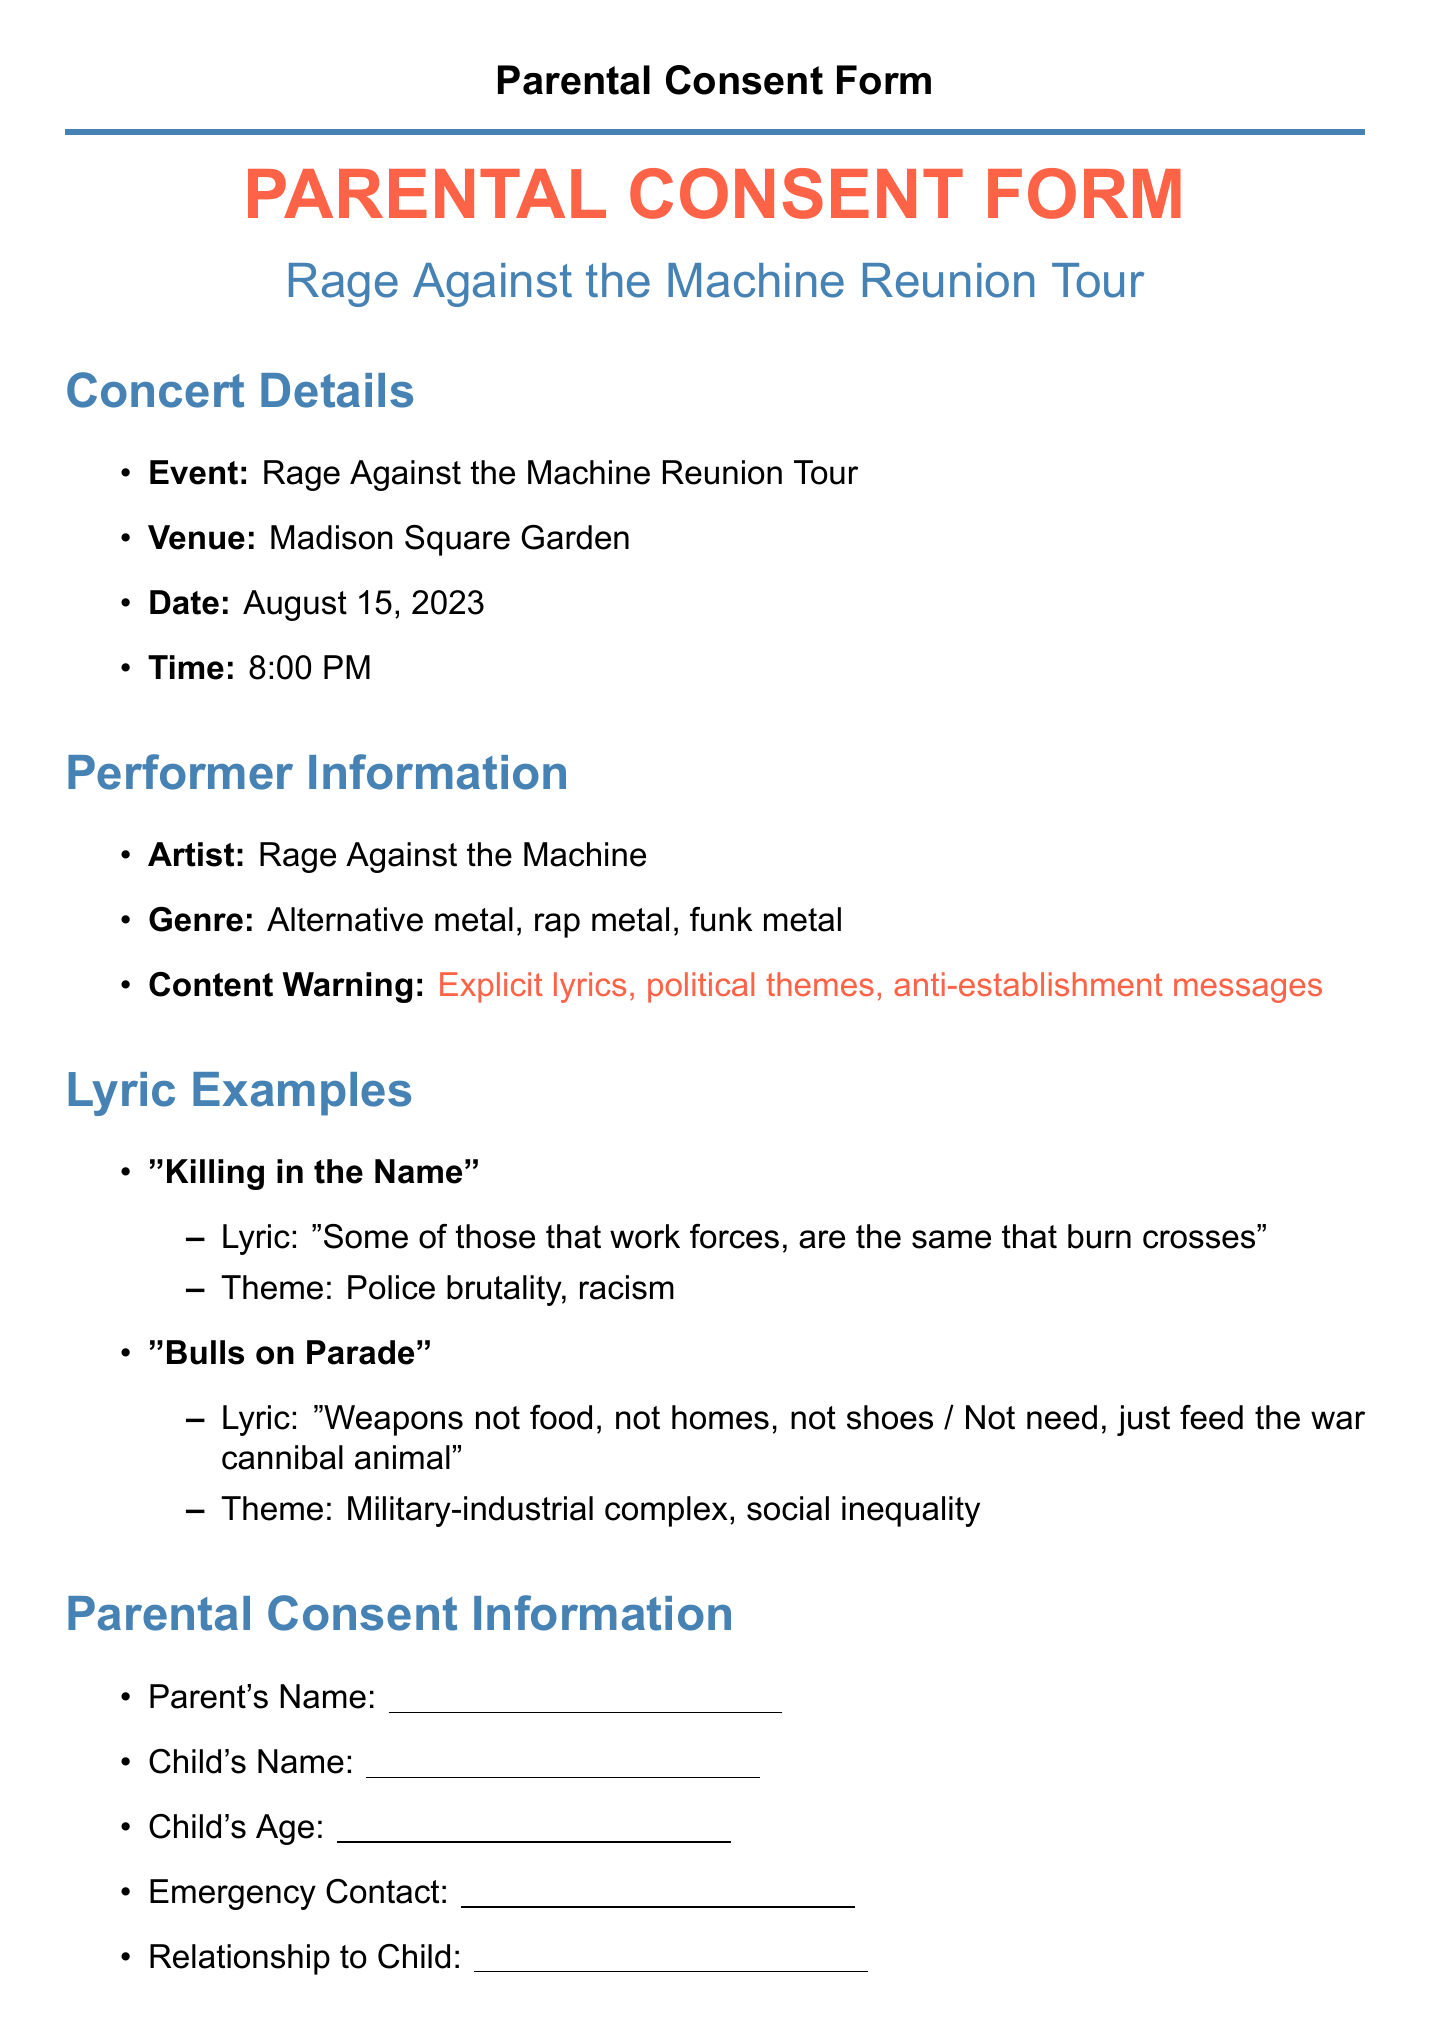What is the event name? The event name is clearly stated in the document as "Rage Against the Machine Reunion Tour."
Answer: Rage Against the Machine Reunion Tour What is the venue for the concert? The document specifies that the concert will take place at Madison Square Garden.
Answer: Madison Square Garden What time does the concert start? The starting time of the concert is mentioned in the document as 8:00 PM.
Answer: 8:00 PM Who is the performing artist? The document lists the performing artist as "Rage Against the Machine."
Answer: Rage Against the Machine What content warning is provided in the document? The document includes a content warning stating "Explicit lyrics, political themes, anti-establishment messages."
Answer: Explicit lyrics, political themes, anti-establishment messages What is one theme of the song "Killing in the Name"? The document identifies the theme of "Killing in the Name" as "Police brutality, racism."
Answer: Police brutality, racism What responsibility do parents accept regarding their child's behavior? The document states that parents accept responsibility for their child's safety and behavior during the event.
Answer: Safety and behavior What is recommended to protect hearing? The document advises that earplugs are strongly recommended to protect hearing.
Answer: Earplugs What must parents discuss with their children before the concert? The document encourages parents to discuss the concert's themes with their children beforehand.
Answer: Concert's themes 